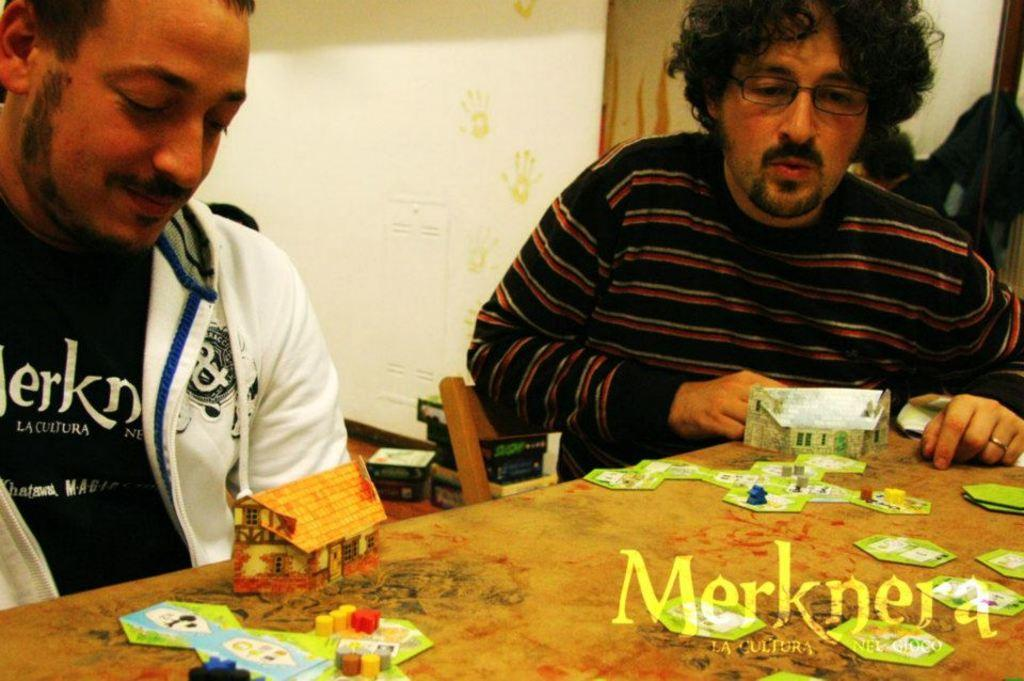What can be seen in the background of the image? There is a wall in the background of the image. What are the two men in the image doing? The two men are sitting on chairs in the image. What is located between the two men? The men are in front of a table. What objects are on the table? There are cardboard houses and paper boards on the table. What type of meal is being prepared on the table in the image? There is no meal being prepared in the image; the table contains cardboard houses and paper boards. Can you see any apples on the table in the image? There are no apples present in the image. 